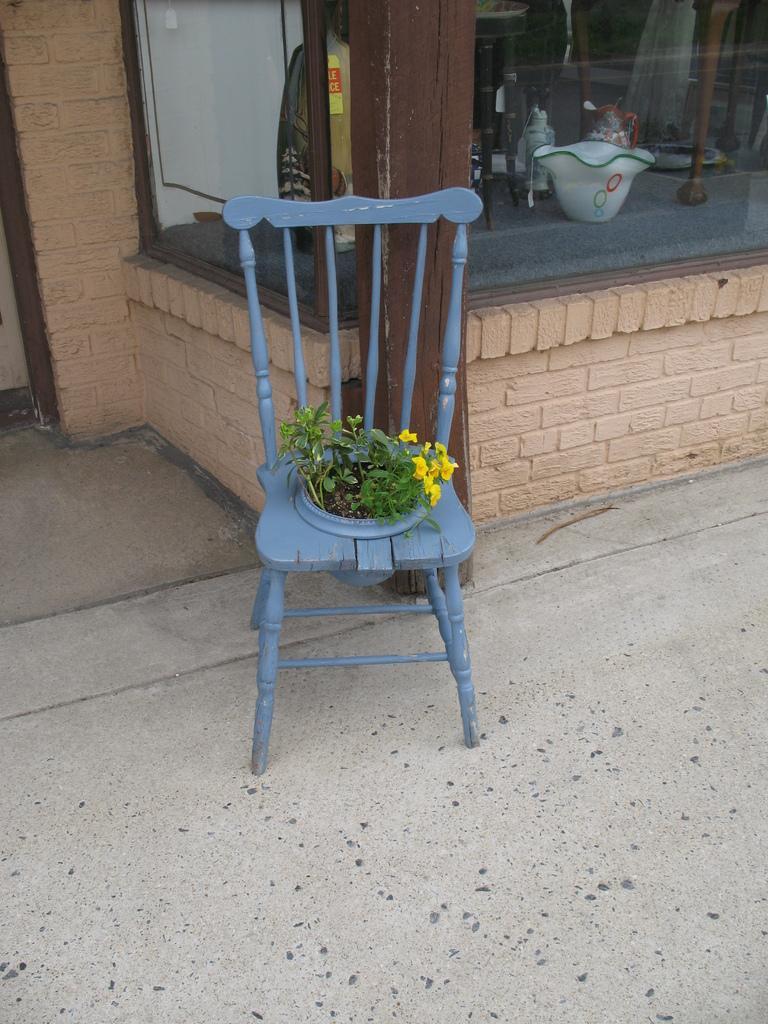Could you give a brief overview of what you see in this image? In the image we can see there is a chair on which plants are growing. 